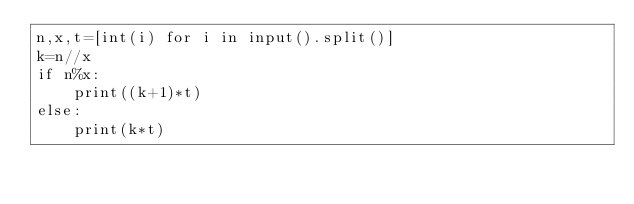<code> <loc_0><loc_0><loc_500><loc_500><_Python_>n,x,t=[int(i) for i in input().split()]
k=n//x
if n%x:
    print((k+1)*t)
else:
    print(k*t)</code> 